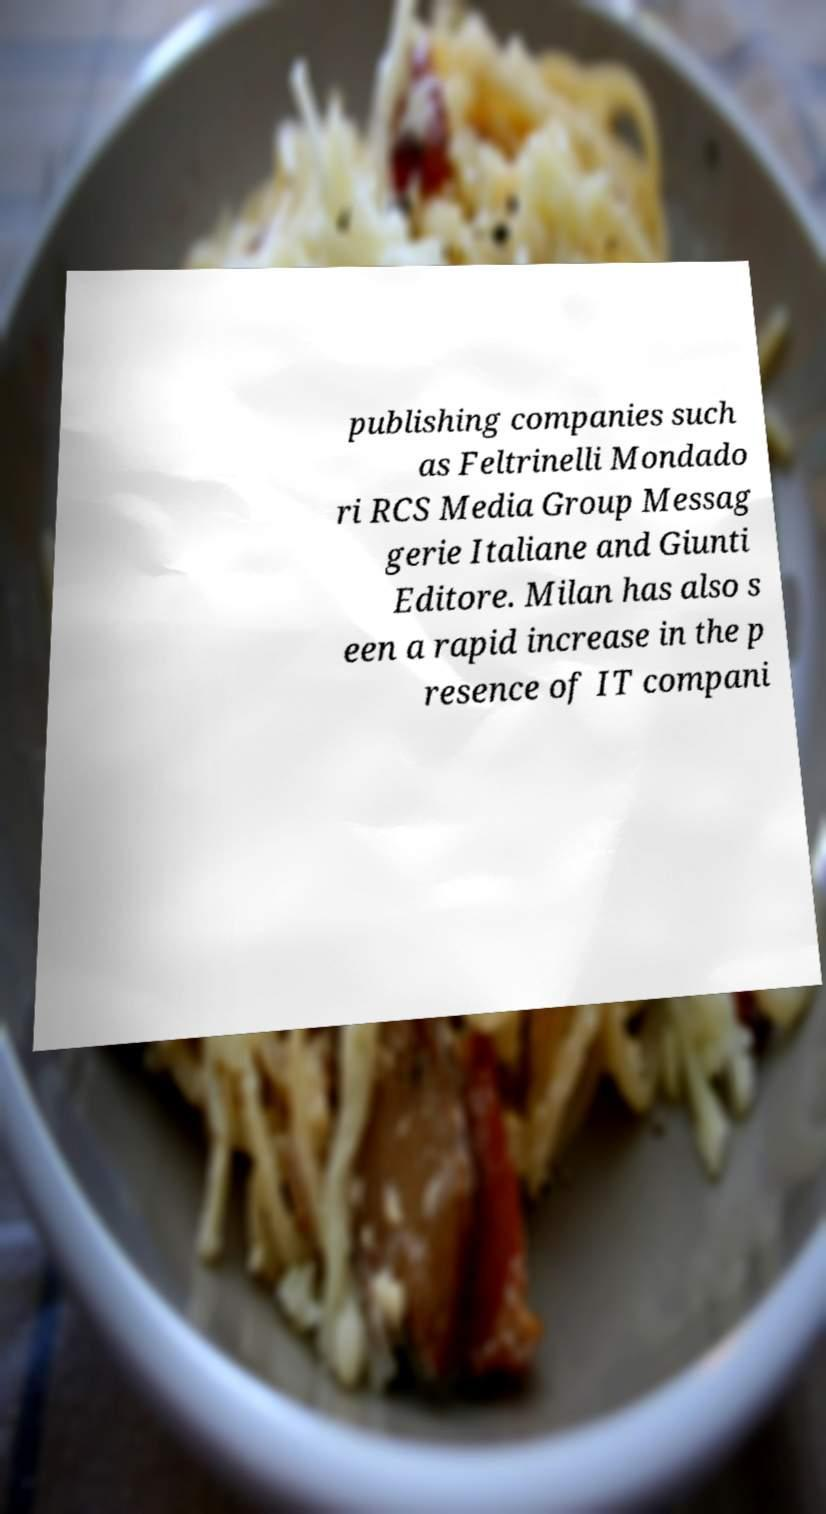What messages or text are displayed in this image? I need them in a readable, typed format. publishing companies such as Feltrinelli Mondado ri RCS Media Group Messag gerie Italiane and Giunti Editore. Milan has also s een a rapid increase in the p resence of IT compani 